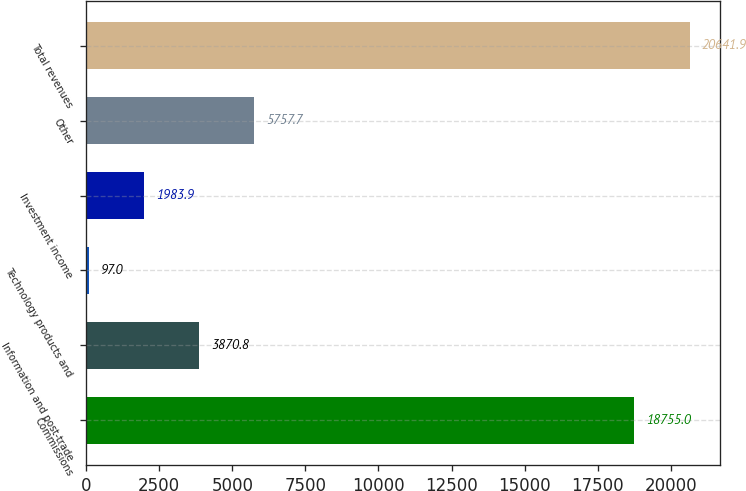Convert chart to OTSL. <chart><loc_0><loc_0><loc_500><loc_500><bar_chart><fcel>Commissions<fcel>Information and post-trade<fcel>Technology products and<fcel>Investment income<fcel>Other<fcel>Total revenues<nl><fcel>18755<fcel>3870.8<fcel>97<fcel>1983.9<fcel>5757.7<fcel>20641.9<nl></chart> 